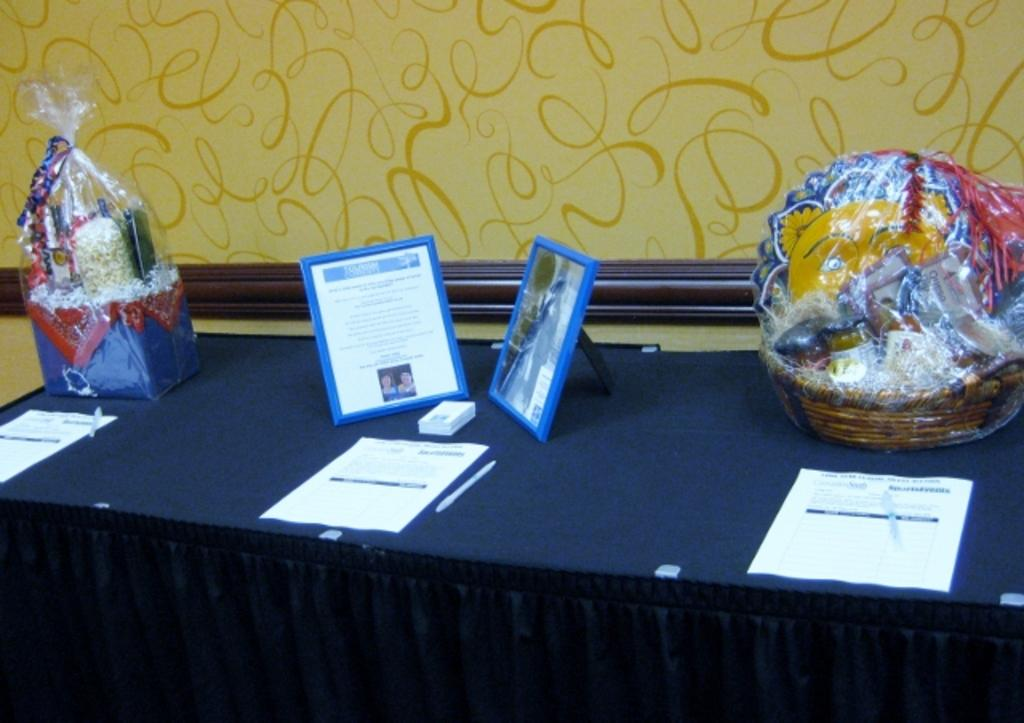What is the main object in the center of the image? There is a table in the middle of the image. What items can be seen on the table? Papers, photo frames, baskets, gifts, cloth, and a pen are on the table. Are there any other items on the table? Yes, there are other items on the table. What can be seen in the background of the image? There is a wall in the background of the image. Is there a spy hiding behind the wall in the image? There is no indication of a spy or any hidden person in the image; it only shows a table with various items and a wall in the background. Can you see any food on the table in the image? No, the image does not show any food items on the table. 